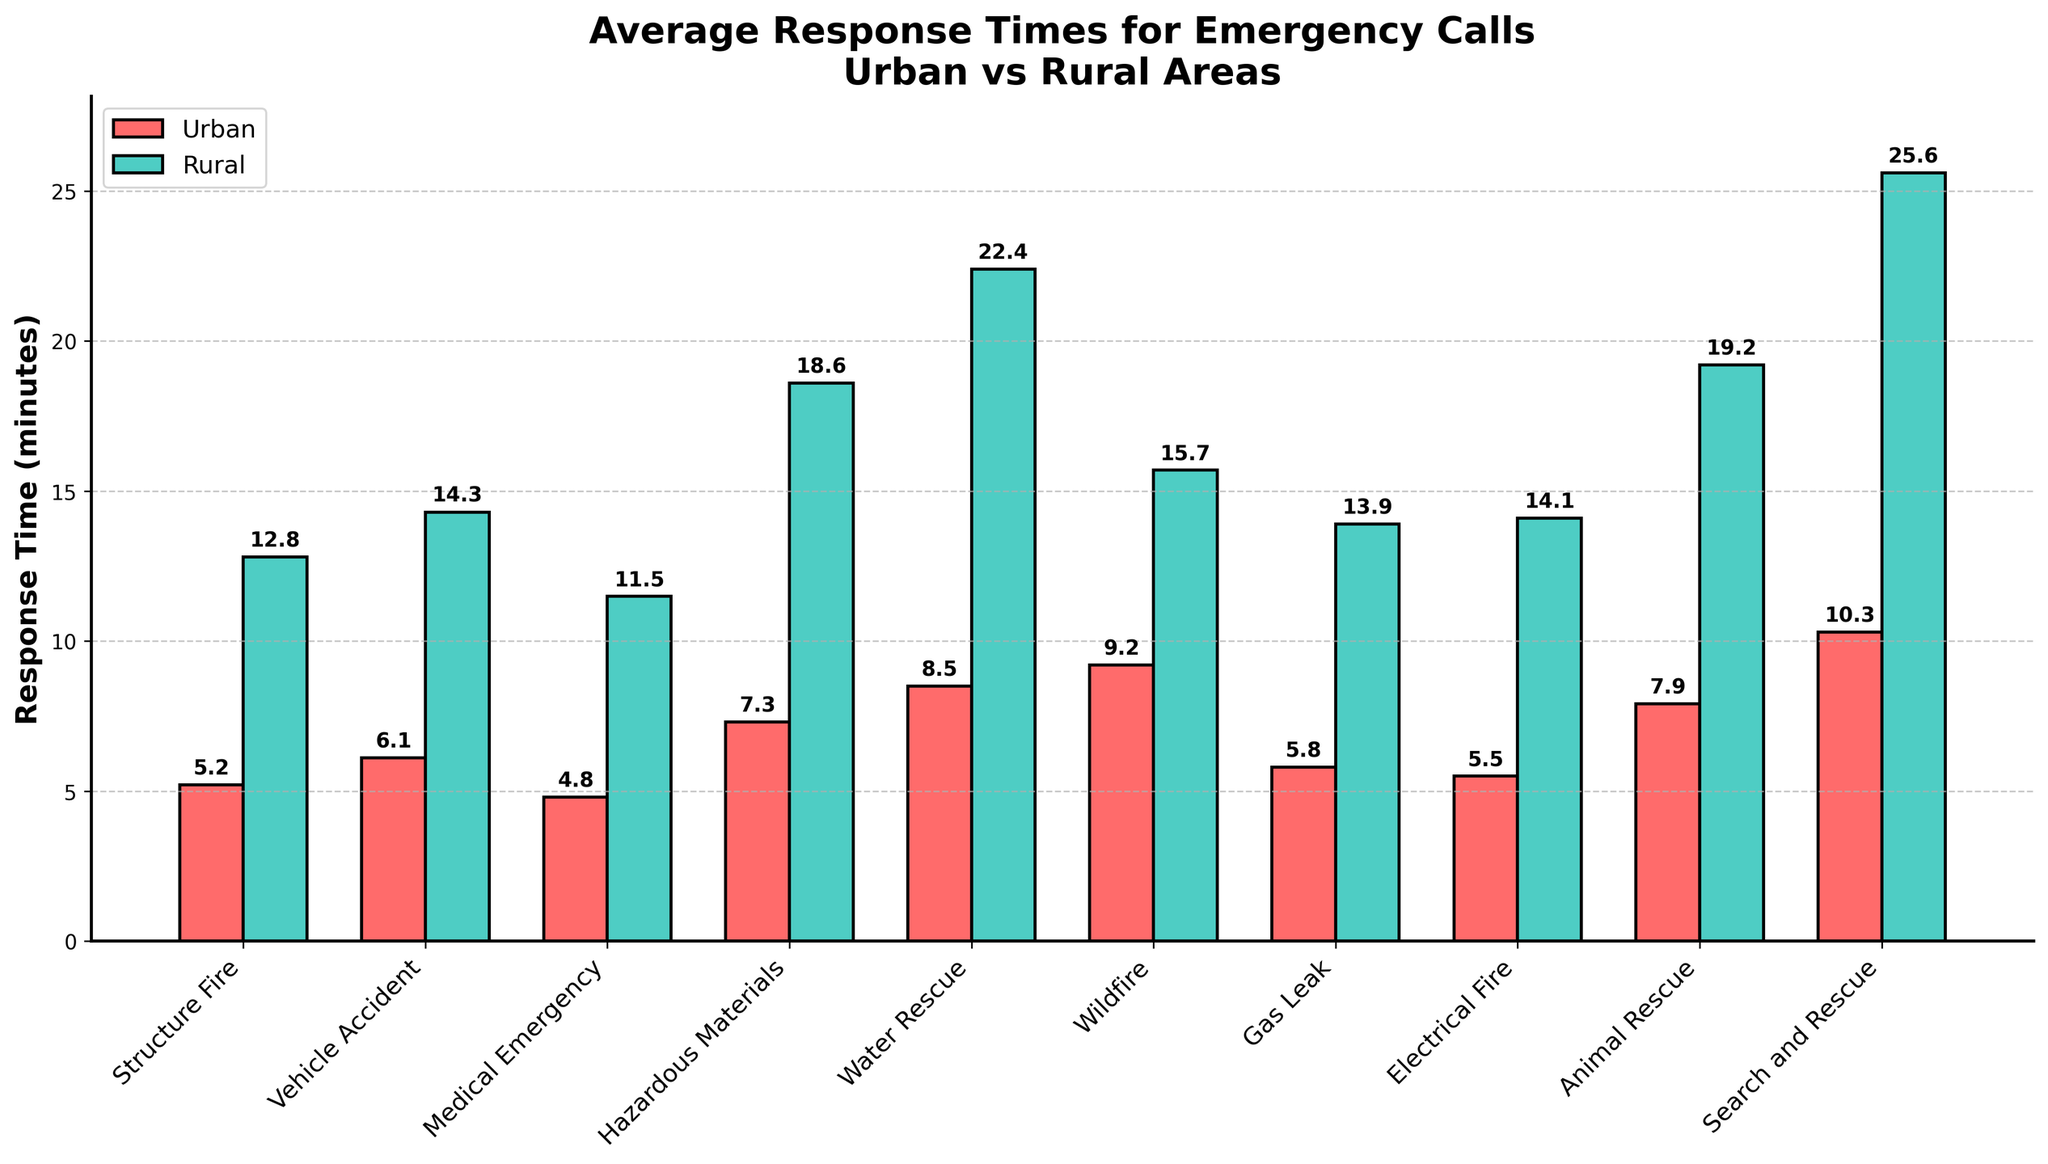Which emergency type has the longest urban response time? To determine the longest urban response time, compare the bars representing urban response times for each emergency type. The longest bar for urban areas corresponds to "Search and Rescue" with a response time of 10.3 minutes.
Answer: Search and Rescue What is the difference between the urban and rural response times for a wildfire? Identify the response times for wildfires in both urban and rural areas. Subtract the urban response time (9.2 minutes) from the rural response time (15.7 minutes). 15.7 - 9.2 = 6.5 minutes.
Answer: 6.5 minutes Which area, urban or rural, has generally lower response times across the emergency types? By visually comparing the heights of the urban and rural bars for each emergency type, the urban bars are consistently shorter than the rural bars, indicating lower response times.
Answer: Urban What are the two emergency types with the smallest difference in response times between urban and rural areas? Calculate the differences between urban and rural response times for each type. The smallest differences are for "Structure Fire" (12.8 - 5.2 = 7.6 minutes) and "Electrical Fire" (14.1 - 5.5 = 8.6 minutes).
Answer: Structure Fire and Electrical Fire How does the response time for hazardous materials compare between urban and rural areas? Look at the bars representing response times for hazardous materials. The rural bar is significantly taller, indicating that rural response times (18.6 minutes) are much higher than urban response times (7.3 minutes).
Answer: Rural is higher Which emergency type shows the greatest discrepancy in response times between urban and rural areas? Observe the differences between the urban and rural bars for all emergency types. "Search and Rescue" shows the greatest difference, with rural response times (25.6 minutes) much higher than urban times (10.3 minutes).
Answer: Search and Rescue If the average urban response time is 7.1 minutes, how does this compare to the average rural response time depicted in the figure? Sum the urban response times (5.2 + 6.1 + 4.8 + 7.3 + 8.5 + 9.2 + 5.8 + 5.5 + 7.9 + 10.3) and divide by the number of data points (10) to verify the average is 7.1 minutes. Calculate the average rural times (12.8 + 14.3 + 11.5 + 18.6 + 22.4 + 15.7 + 13.9 + 14.1 + 19.2 + 25.6) / 10 = 16.8 minutes. Compare 7.1 to 16.8.
Answer: Urban average is lower Which color bars represent rural response times in the graph? Observe the color legend in the figure, where rural areas are represented by green bars.
Answer: Green 